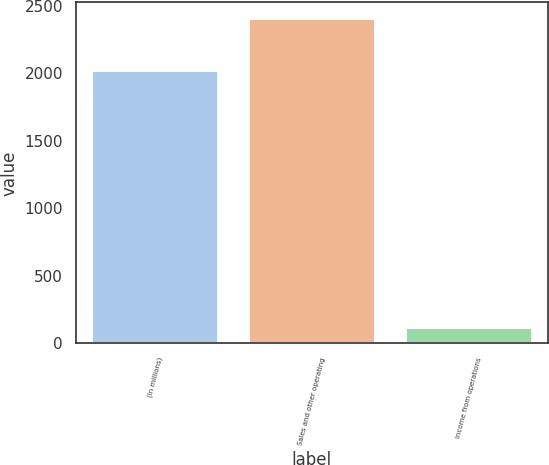<chart> <loc_0><loc_0><loc_500><loc_500><bar_chart><fcel>(In millions)<fcel>Sales and other operating<fcel>Income from operations<nl><fcel>2014<fcel>2403<fcel>113<nl></chart> 